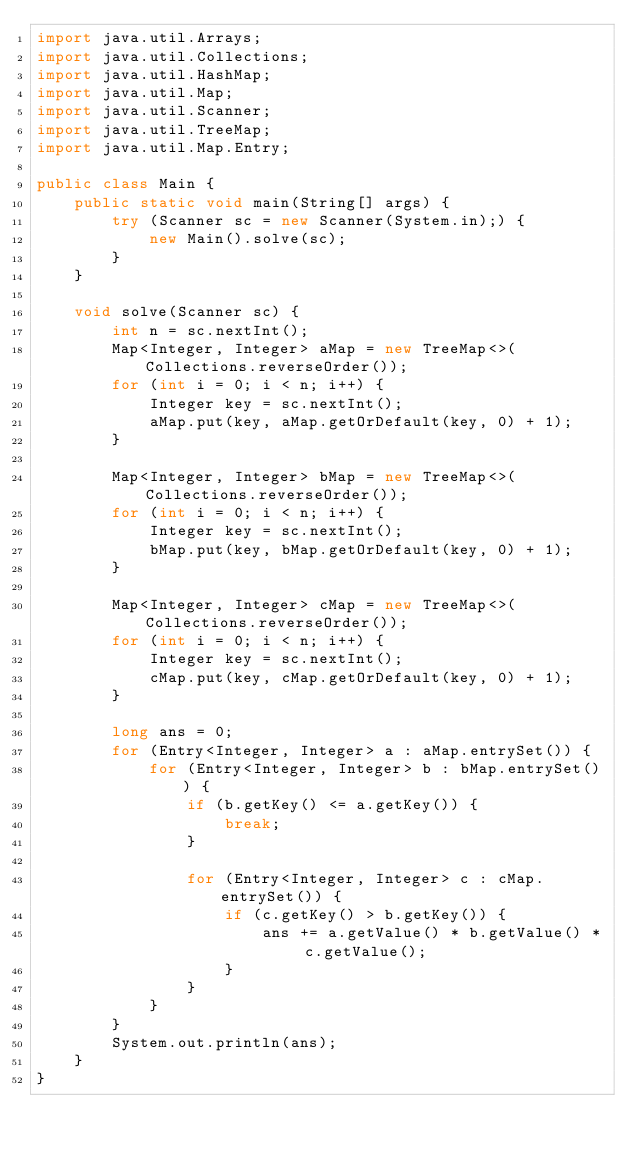Convert code to text. <code><loc_0><loc_0><loc_500><loc_500><_Java_>import java.util.Arrays;
import java.util.Collections;
import java.util.HashMap;
import java.util.Map;
import java.util.Scanner;
import java.util.TreeMap;
import java.util.Map.Entry;

public class Main {
    public static void main(String[] args) {
        try (Scanner sc = new Scanner(System.in);) {
            new Main().solve(sc);
        }
    }

    void solve(Scanner sc) {
        int n = sc.nextInt();
        Map<Integer, Integer> aMap = new TreeMap<>(Collections.reverseOrder());
        for (int i = 0; i < n; i++) {
            Integer key = sc.nextInt();
            aMap.put(key, aMap.getOrDefault(key, 0) + 1);
        }

        Map<Integer, Integer> bMap = new TreeMap<>(Collections.reverseOrder());
        for (int i = 0; i < n; i++) {
            Integer key = sc.nextInt();
            bMap.put(key, bMap.getOrDefault(key, 0) + 1);
        }

        Map<Integer, Integer> cMap = new TreeMap<>(Collections.reverseOrder());
        for (int i = 0; i < n; i++) {
            Integer key = sc.nextInt();
            cMap.put(key, cMap.getOrDefault(key, 0) + 1);
        }

        long ans = 0;
        for (Entry<Integer, Integer> a : aMap.entrySet()) {
            for (Entry<Integer, Integer> b : bMap.entrySet()) {
                if (b.getKey() <= a.getKey()) {
                    break;
                }

                for (Entry<Integer, Integer> c : cMap.entrySet()) {
                    if (c.getKey() > b.getKey()) {
                        ans += a.getValue() * b.getValue() * c.getValue();
                    }
                }
            }
        }
        System.out.println(ans);
    }
}
</code> 